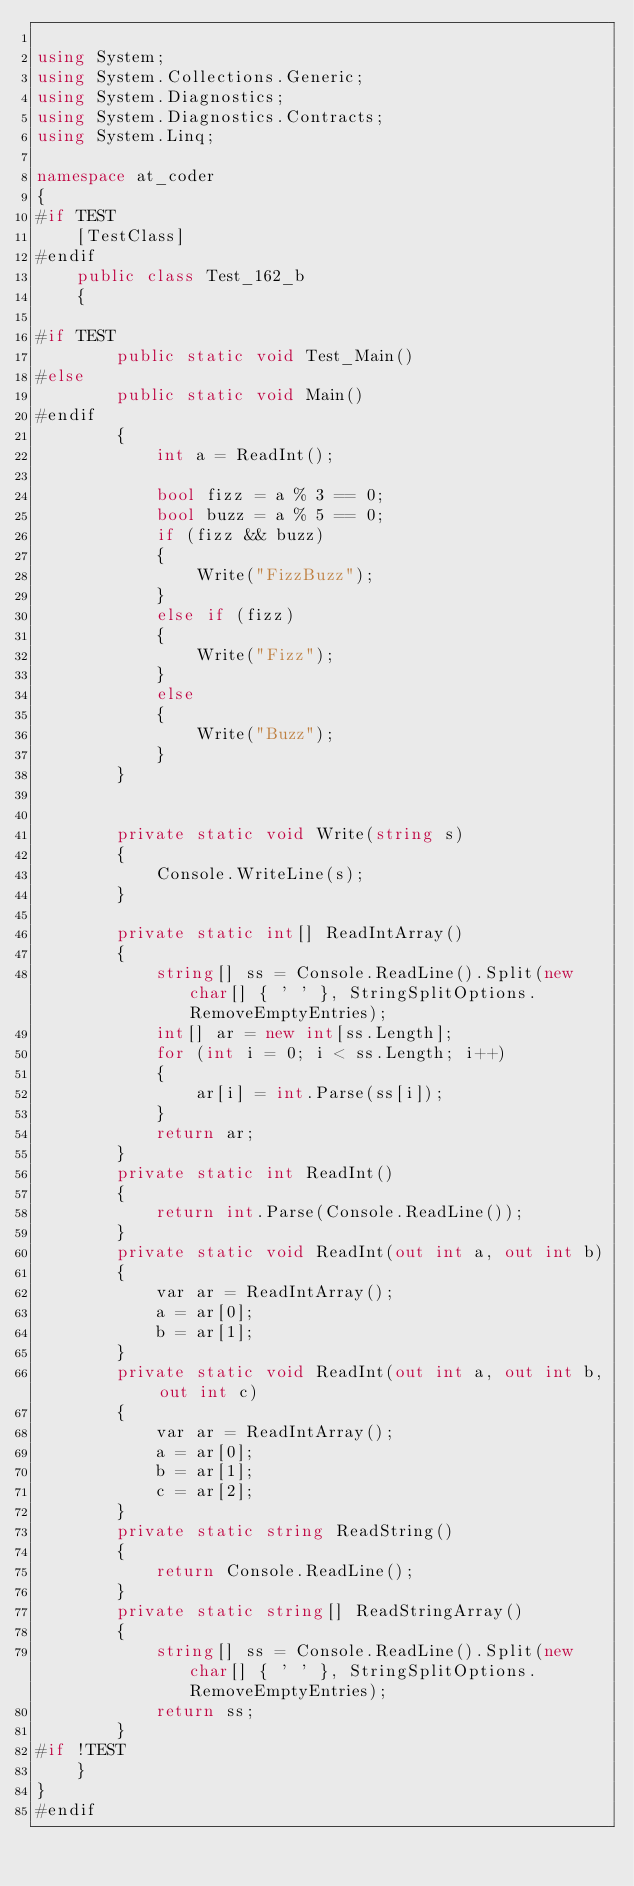Convert code to text. <code><loc_0><loc_0><loc_500><loc_500><_C#_>
using System;
using System.Collections.Generic;
using System.Diagnostics;
using System.Diagnostics.Contracts;
using System.Linq;

namespace at_coder
{
#if TEST
    [TestClass]
#endif
    public class Test_162_b
    {

#if TEST
        public static void Test_Main()
#else
        public static void Main()
#endif
        {
            int a = ReadInt();

            bool fizz = a % 3 == 0;
            bool buzz = a % 5 == 0;
            if (fizz && buzz)
            {
                Write("FizzBuzz");
            }
            else if (fizz)
            {
                Write("Fizz");
            }
            else
            {
                Write("Buzz");
            }
        }


        private static void Write(string s)
        {
            Console.WriteLine(s);
        }

        private static int[] ReadIntArray()
        {
            string[] ss = Console.ReadLine().Split(new char[] { ' ' }, StringSplitOptions.RemoveEmptyEntries);
            int[] ar = new int[ss.Length];
            for (int i = 0; i < ss.Length; i++)
            {
                ar[i] = int.Parse(ss[i]);
            }
            return ar;
        }
        private static int ReadInt()
        {
            return int.Parse(Console.ReadLine());
        }
        private static void ReadInt(out int a, out int b)
        {
            var ar = ReadIntArray();
            a = ar[0];
            b = ar[1];
        }
        private static void ReadInt(out int a, out int b, out int c)
        {
            var ar = ReadIntArray();
            a = ar[0];
            b = ar[1];
            c = ar[2];
        }
        private static string ReadString()
        {
            return Console.ReadLine();
        }
        private static string[] ReadStringArray()
        {
            string[] ss = Console.ReadLine().Split(new char[] { ' ' }, StringSplitOptions.RemoveEmptyEntries);
            return ss;
        }
#if !TEST
    }
}
#endif</code> 